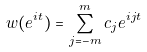Convert formula to latex. <formula><loc_0><loc_0><loc_500><loc_500>w ( e ^ { i t } ) = \sum _ { j = - m } ^ { m } c _ { j } e ^ { i j t }</formula> 